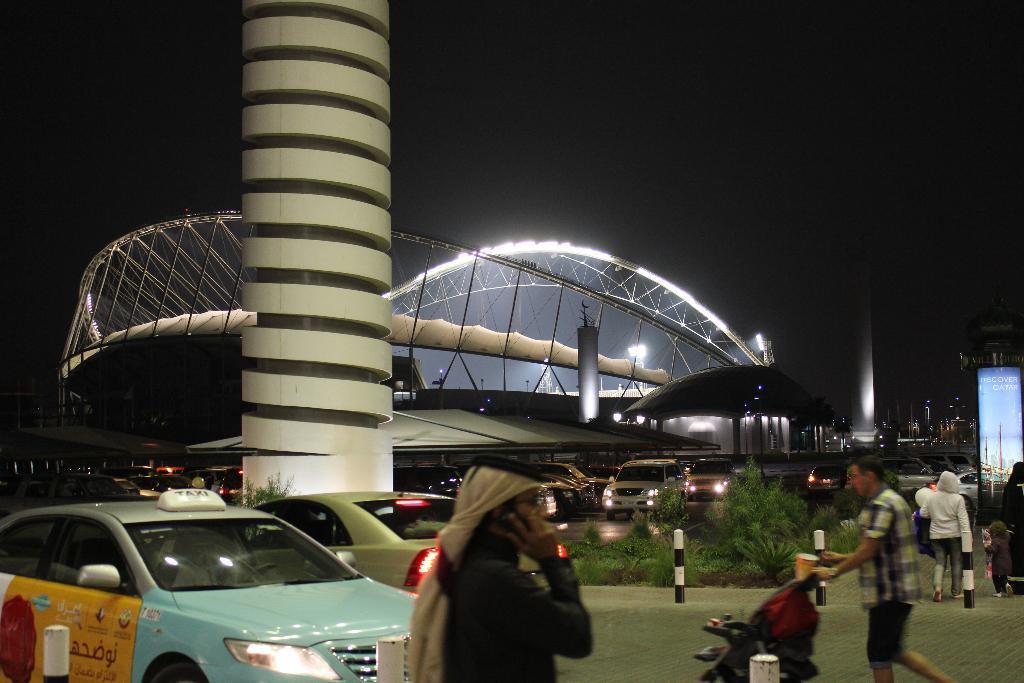Could you give a brief overview of what you see in this image? In this image we can see architecture, vehicles, pillars, rods, hoarding, grass, lights, stroller, road, and plants. In the background there is sky. 